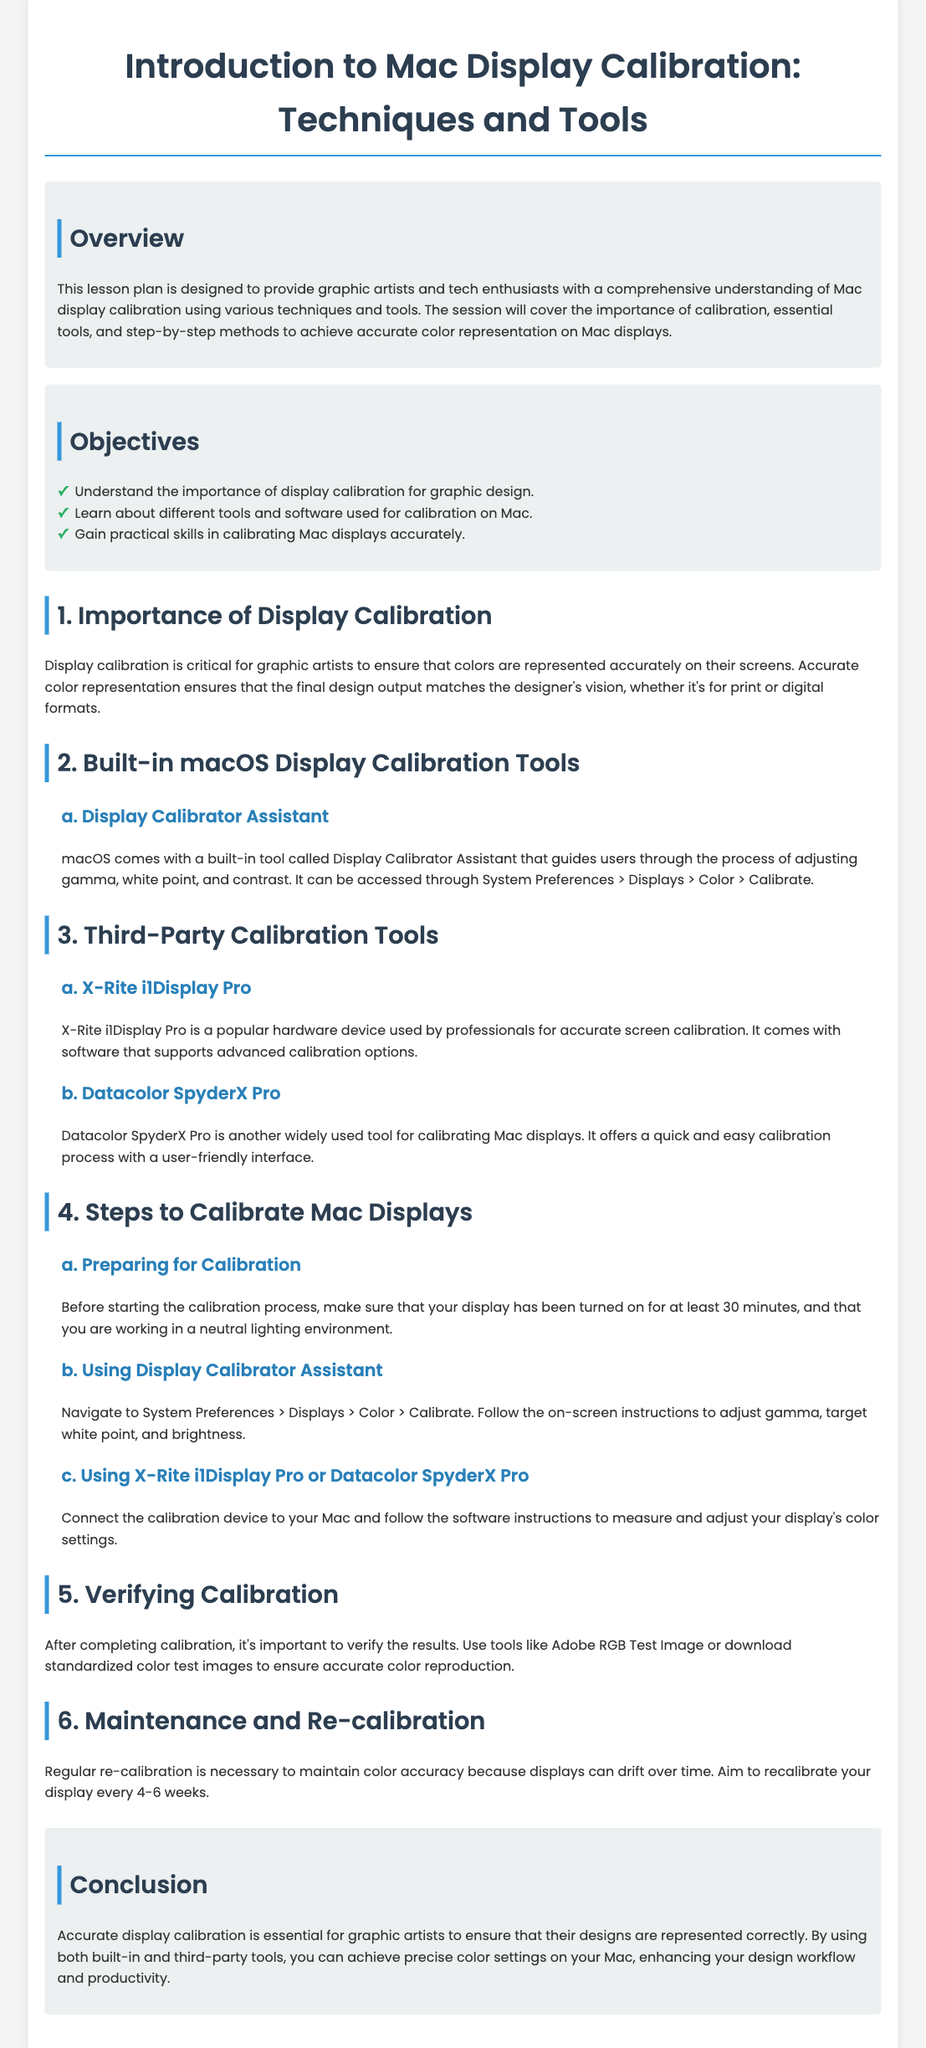What is the title of the lesson plan? The title of the lesson plan is provided at the beginning of the document.
Answer: Introduction to Mac Display Calibration: Techniques and Tools What is one built-in tool mentioned for display calibration? The document lists specific tools and mentions one built-in tool specific to macOS.
Answer: Display Calibrator Assistant How often should you aim to re-calibrate your display? The lesson mentions a recommended frequency for re-calibration to maintain accuracy.
Answer: Every 4-6 weeks What is the purpose of calibration for graphic artists? The document explains the significance of calibration, especially for graphic design.
Answer: Accurate color representation What are the two third-party tools mentioned for calibration? The document specifically names two popular third-party calibration tools used by professionals.
Answer: X-Rite i1Display Pro, Datacolor SpyderX Pro What is the first step to prepare for calibration? The document states the initial requirement before starting the calibration process.
Answer: Turn on the display for at least 30 minutes What is the main focus of the lesson plan? The document provides an overview explaining what the lesson plan is designed for.
Answer: Understanding Mac display calibration techniques and tools What should you use to verify calibration after completion? The lesson plan mentions a method to check the results of the calibration process.
Answer: Adobe RGB Test Image 